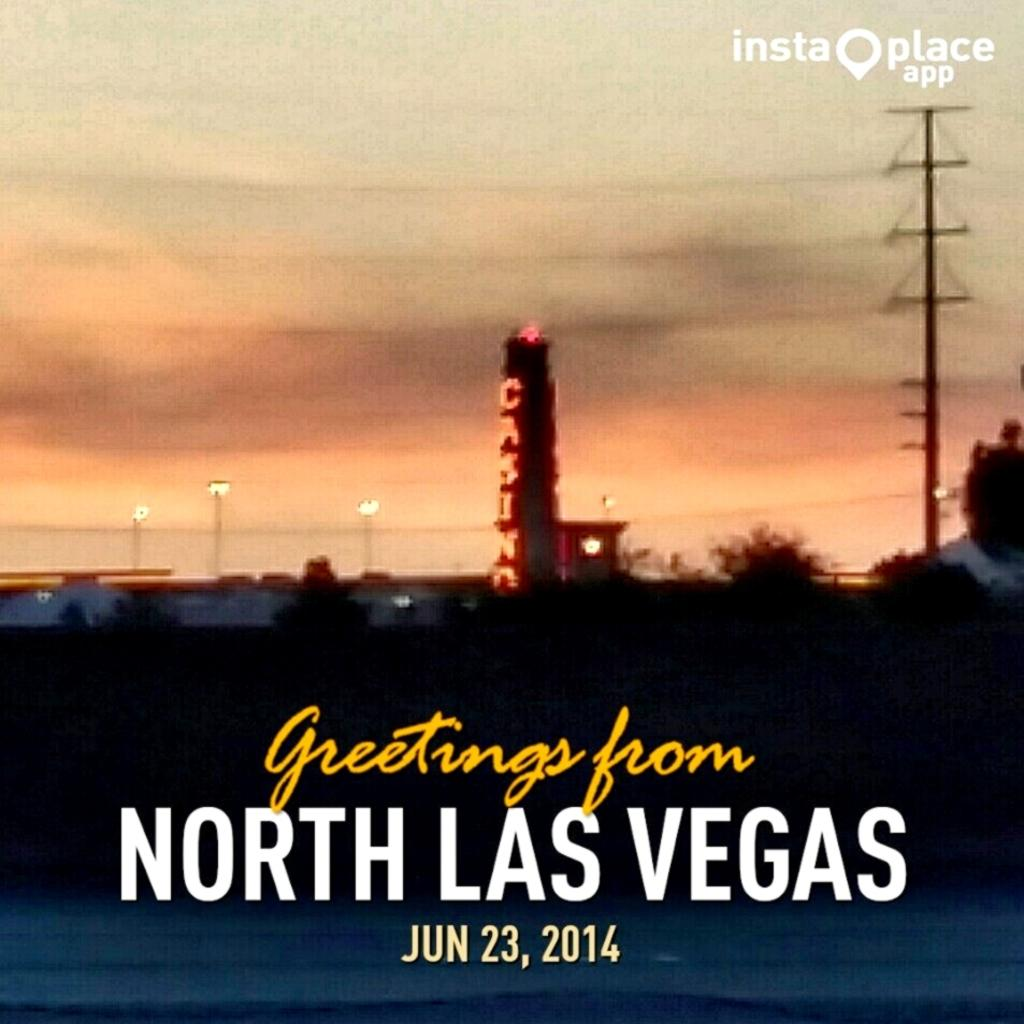<image>
Provide a brief description of the given image. Poster that says "Greetings from North Las Vegas" and the date at June 23rd. 